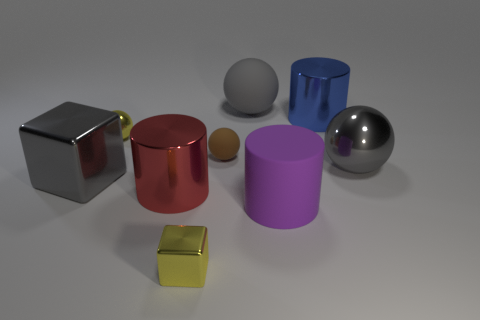Which object stands out the most to you and why? The chrome cube on the left stands out due to its reflective surface that catches the light and the environment, creating a mirror-like effect that is striking in contrast to the more muted or monochromatic surfaces of the other objects. 